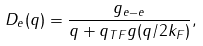Convert formula to latex. <formula><loc_0><loc_0><loc_500><loc_500>D _ { e } ( { q } ) = \frac { g _ { e - e } } { q + q _ { T F } g ( q / 2 k _ { F } ) } ,</formula> 